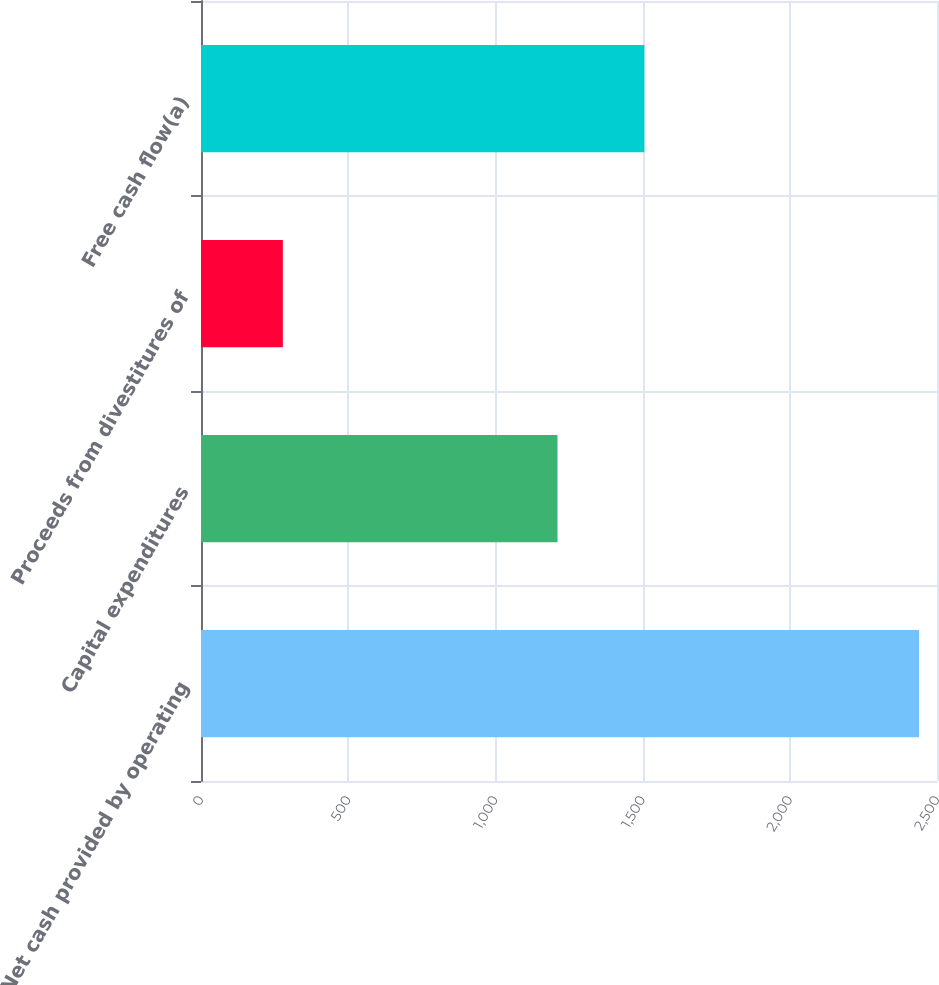Convert chart. <chart><loc_0><loc_0><loc_500><loc_500><bar_chart><fcel>Net cash provided by operating<fcel>Capital expenditures<fcel>Proceeds from divestitures of<fcel>Free cash flow(a)<nl><fcel>2439<fcel>1211<fcel>278<fcel>1506<nl></chart> 